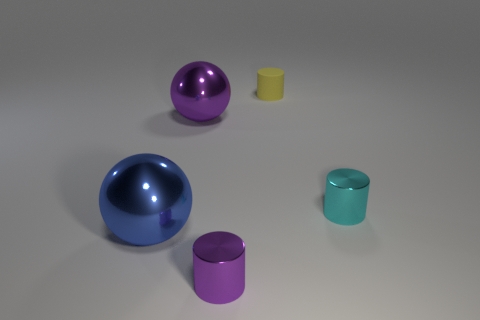Add 2 blue spheres. How many objects exist? 7 Subtract all cylinders. How many objects are left? 2 Subtract all large yellow rubber things. Subtract all tiny yellow matte cylinders. How many objects are left? 4 Add 2 purple cylinders. How many purple cylinders are left? 3 Add 4 tiny cyan things. How many tiny cyan things exist? 5 Subtract 1 cyan cylinders. How many objects are left? 4 